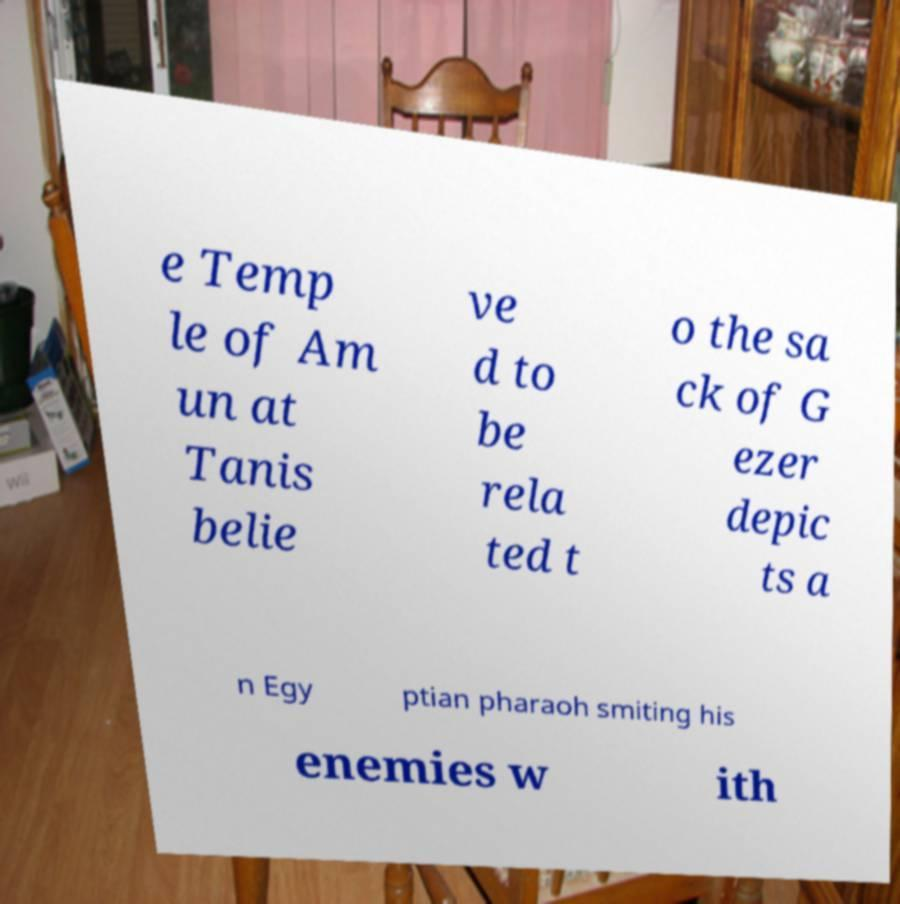Please read and relay the text visible in this image. What does it say? e Temp le of Am un at Tanis belie ve d to be rela ted t o the sa ck of G ezer depic ts a n Egy ptian pharaoh smiting his enemies w ith 